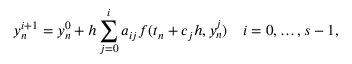<formula> <loc_0><loc_0><loc_500><loc_500>y _ { n } ^ { i + 1 } = y _ { n } ^ { 0 } + h \sum _ { j = 0 } ^ { i } a _ { i j } f ( t _ { n } + c _ { j } h , y _ { n } ^ { j } ) \quad i = 0 , \dots , s - 1 ,</formula> 